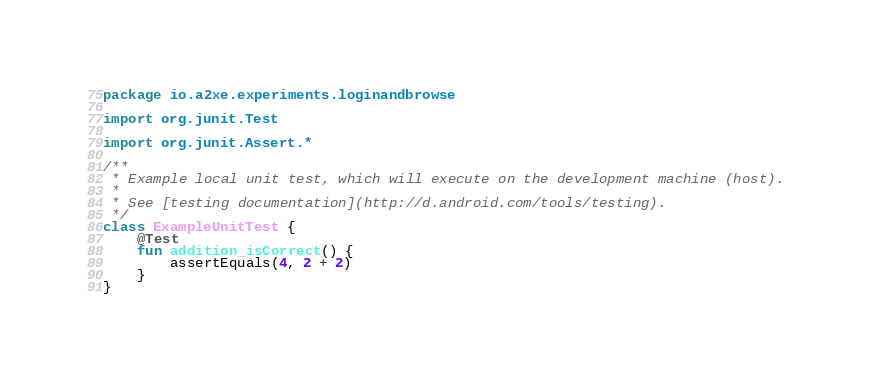<code> <loc_0><loc_0><loc_500><loc_500><_Kotlin_>package io.a2xe.experiments.loginandbrowse

import org.junit.Test

import org.junit.Assert.*

/**
 * Example local unit test, which will execute on the development machine (host).
 *
 * See [testing documentation](http://d.android.com/tools/testing).
 */
class ExampleUnitTest {
    @Test
    fun addition_isCorrect() {
        assertEquals(4, 2 + 2)
    }
}
</code> 